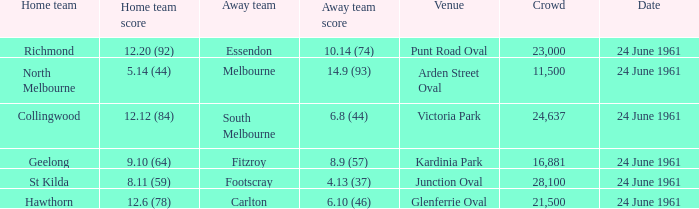What is the date of the game where the home team scored 9.10 (64)? 24 June 1961. 